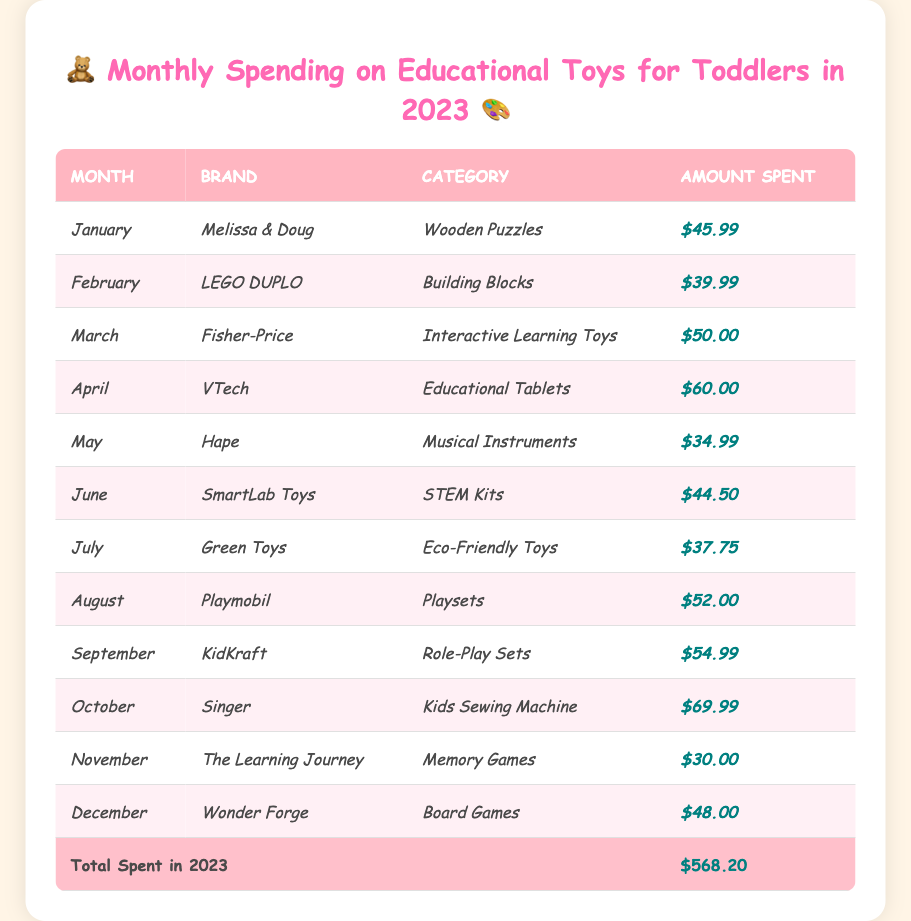What was the highest amount spent on a single toy in 2023? The highest amount spent is $69.99 for the Kids Sewing Machine in October.
Answer: $69.99 Which month saw the least amount spent on educational toys? The least amount spent was $30.00 in November for Memory Games.
Answer: $30.00 What is the total amount spent on educational toys by July? The amounts spent from January to July are: $45.99 (Jan) + $39.99 (Feb) + $50.00 (Mar) + $60.00 (Apr) + $34.99 (May) + $44.50 (Jun) + $37.75 (Jul) = $363.22.
Answer: $363.22 What is the average monthly spending on educational toys for the entire year? The total spending for the year is $568.20, and dividing by 12 months gives an average of $568.20 / 12 ≈ $47.35.
Answer: $47.35 Did spending increase from March to April? The amount spent in March was $50.00 and in April was $60.00, indicating an increase of $10.00.
Answer: Yes How much was spent on interactive learning toys? The only entry for interactive learning toys is $50.00 from Fisher-Price in March, so the total spent is $50.00.
Answer: $50.00 Which brand had the highest expenditure in a single month? October had the highest expenditure of $69.99 on a Kids Sewing Machine from the brand Singer.
Answer: Singer What was the total amount spent on STEM Kits and Educational Tablets combined? The amount spent on STEM Kits was $44.50 and on Educational Tablets was $60.00, so the total is $44.50 + $60.00 = $104.50.
Answer: $104.50 What category had the least amount spent in December? In December, $48.00 was spent on Board Games, and this is the only entry for that month, indicating it was the amount for that month.
Answer: Board Games What was the spending trend from January to December? The spending varied each month with increases in some months and decreases in others, ultimately totaling $568.20 for the year.
Answer: Mixed trend 